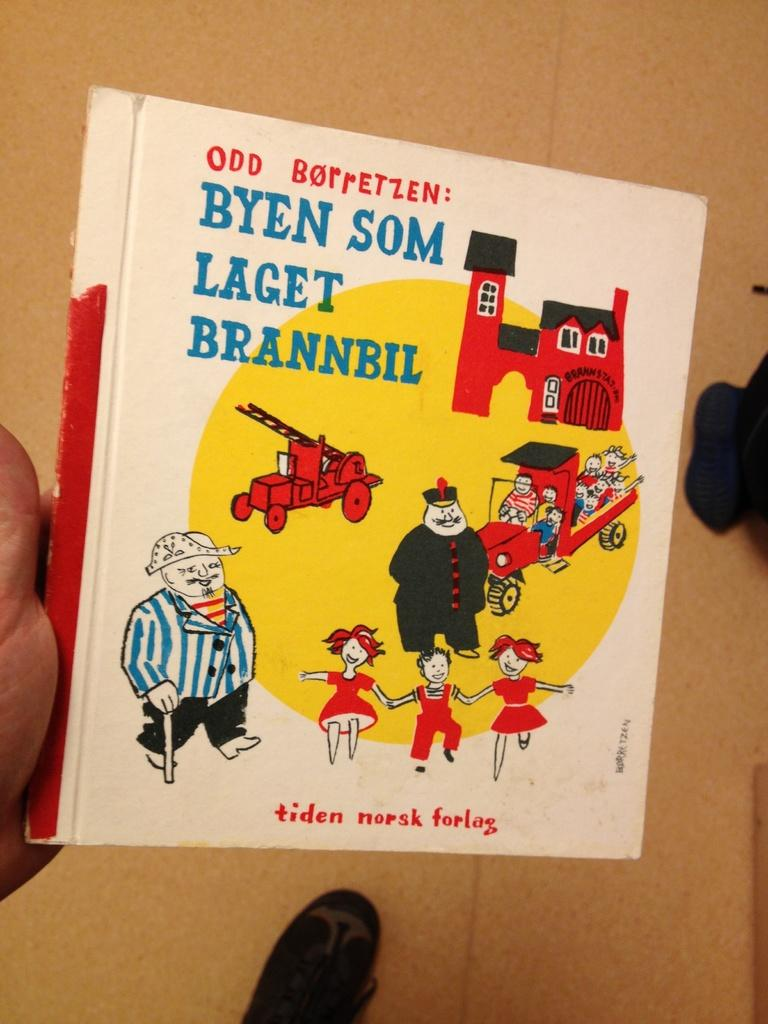Who or what is present in the image? There is a person in the image. What is the person holding in the image? The person is holding a book. What can be seen on the book? There are animated images on the book. What type of canvas is the person using to paint in the image? There is no canvas present in the image, nor is the person painting. 